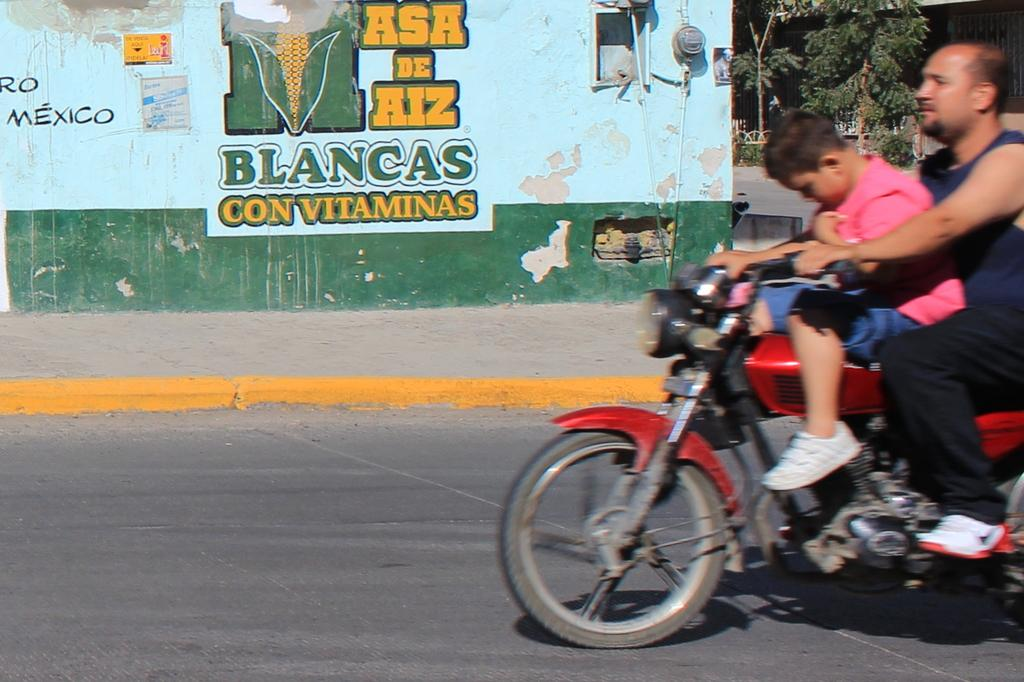What can be seen in the background of the image? There is a wall and trees in the background of the image. What is present in the foreground of the image? There is a road in the image. How many people are in the image? There is a man and a boy in the image. What is the boy doing in the image? The boy is riding a bike. What type of beef is being cooked on the sheet in the image? There is no beef or sheet present in the image. What is the coil used for in the image? There is no coil present in the image. 